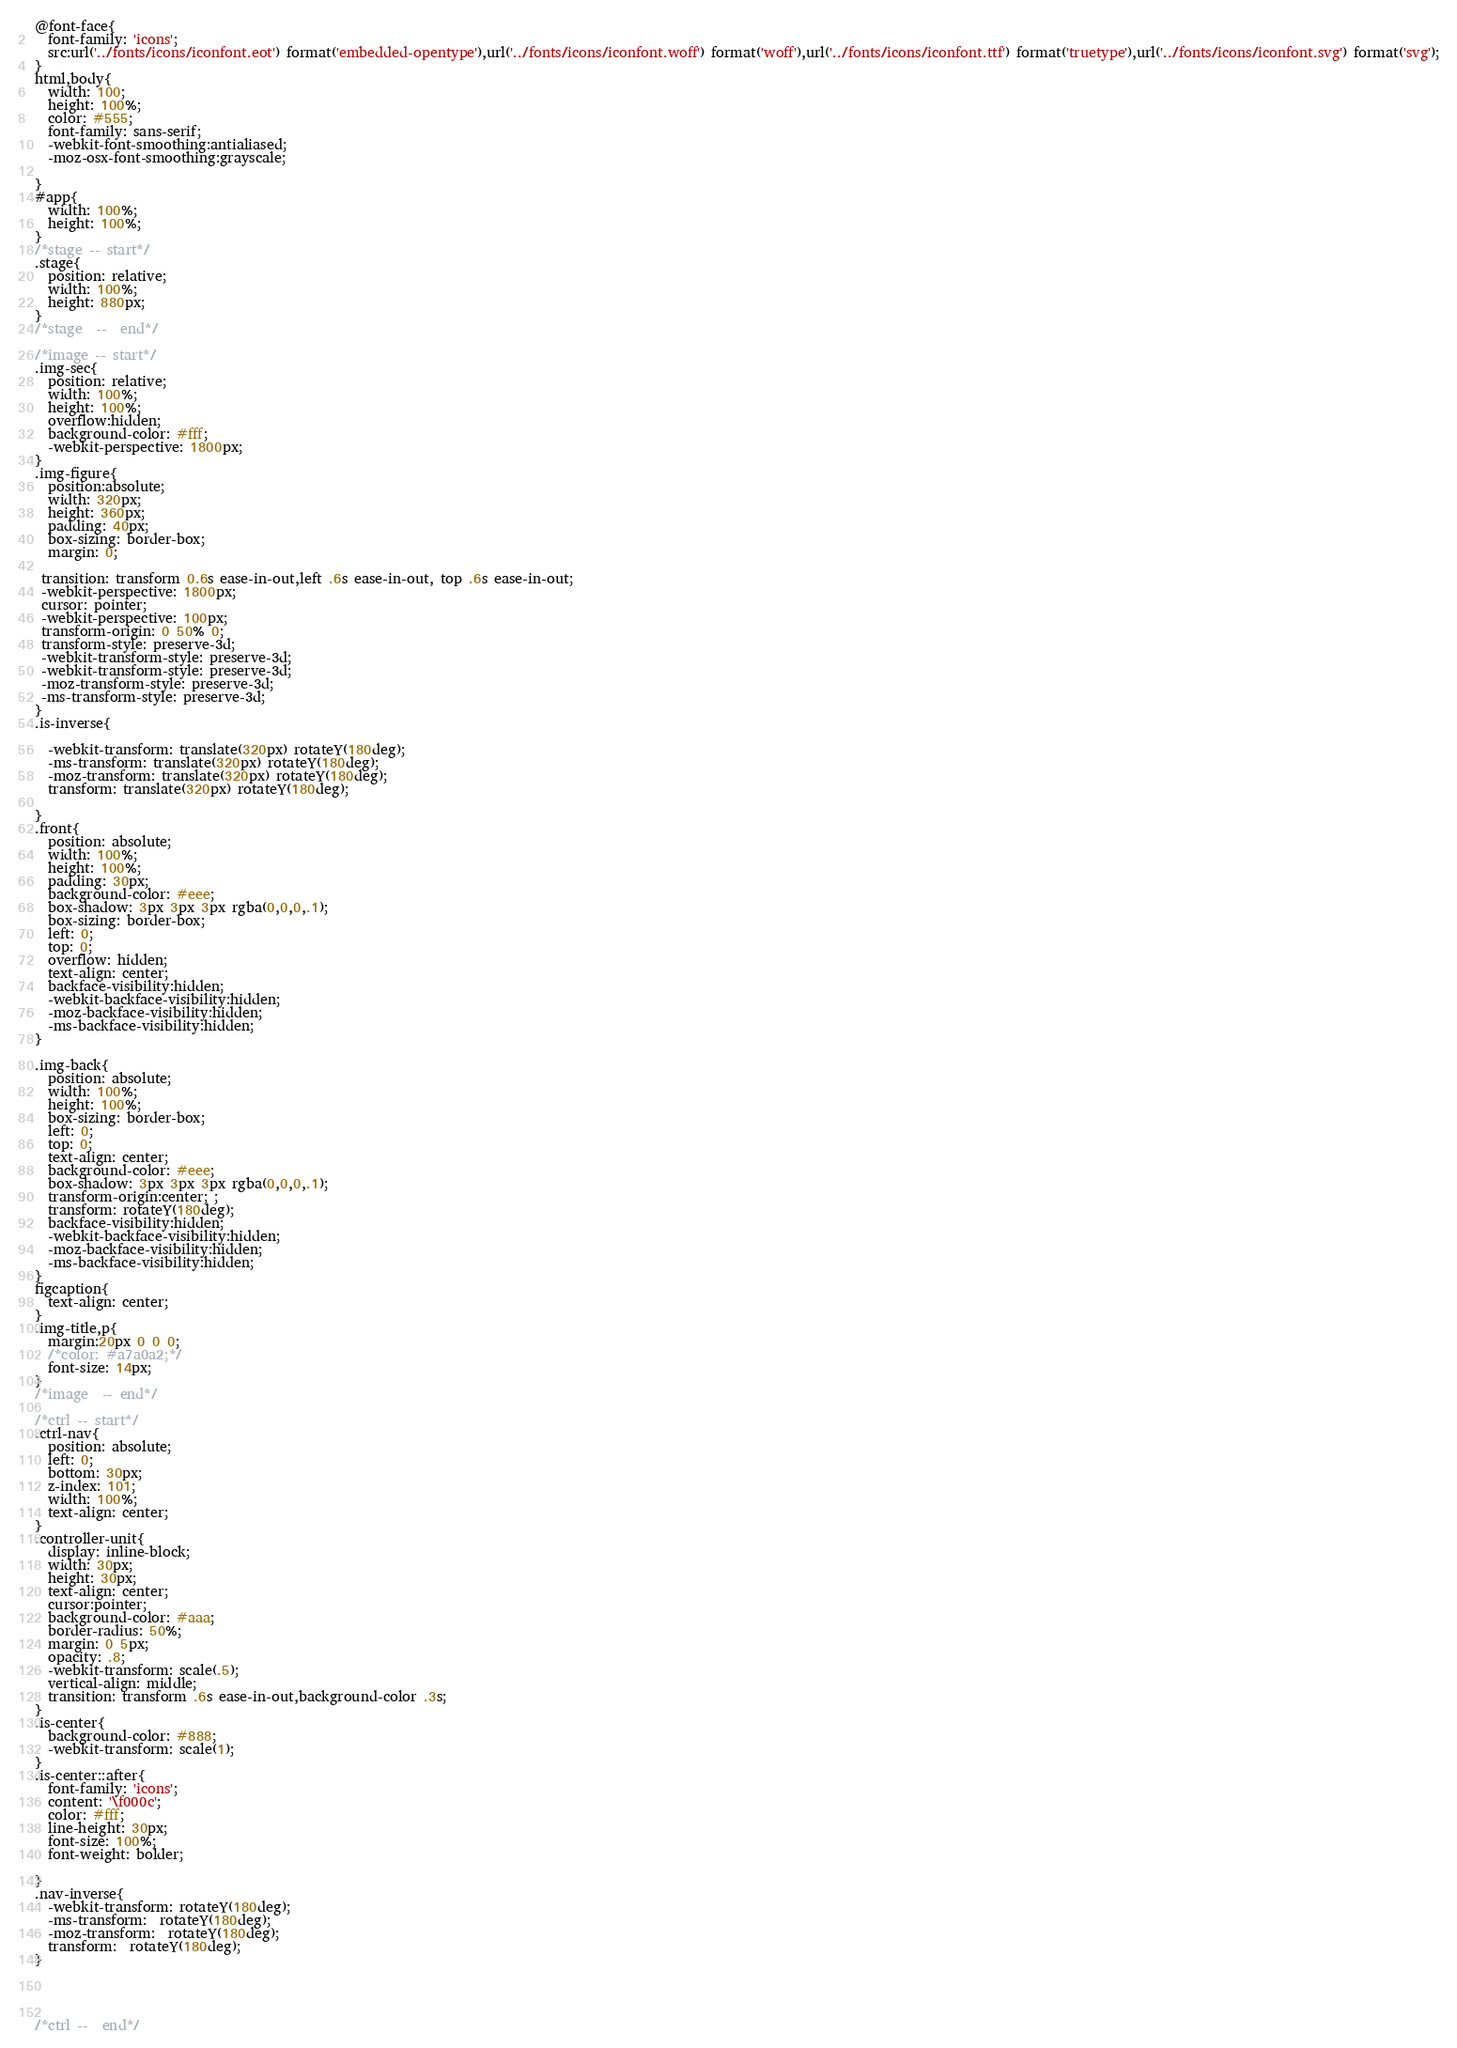<code> <loc_0><loc_0><loc_500><loc_500><_CSS_>@font-face{
  font-family: 'icons';
  src:url('../fonts/icons/iconfont.eot') format('embedded-opentype'),url('../fonts/icons/iconfont.woff') format('woff'),url('../fonts/icons/iconfont.ttf') format('truetype'),url('../fonts/icons/iconfont.svg') format('svg');
}
html,body{
  width: 100;
  height: 100%;
  color: #555;
  font-family: sans-serif;
  -webkit-font-smoothing:antialiased;
  -moz-osx-font-smoothing:grayscale;

}
#app{
  width: 100%;
  height: 100%;
}
/*stage -- start*/
.stage{
  position: relative;
  width: 100%;
  height: 880px;
}
/*stage  --  end*/

/*image -- start*/
.img-sec{
  position: relative;
  width: 100%;
  height: 100%;
  overflow:hidden;
  background-color: #fff;
  -webkit-perspective: 1800px;
}
.img-figure{
  position:absolute;
  width: 320px;
  height: 360px;
  padding: 40px;
  box-sizing: border-box;
  margin: 0;
 
 transition: transform 0.6s ease-in-out,left .6s ease-in-out, top .6s ease-in-out;
 -webkit-perspective: 1800px;
 cursor: pointer;
 -webkit-perspective: 100px;
 transform-origin: 0 50% 0;
 transform-style: preserve-3d;
 -webkit-transform-style: preserve-3d;
 -webkit-transform-style: preserve-3d;
 -moz-transform-style: preserve-3d;
 -ms-transform-style: preserve-3d;
}
.is-inverse{
 
  -webkit-transform: translate(320px) rotateY(180deg);
  -ms-transform: translate(320px) rotateY(180deg);
  -moz-transform: translate(320px) rotateY(180deg);
  transform: translate(320px) rotateY(180deg);

}
.front{
  position: absolute;
  width: 100%;
  height: 100%;
  padding: 30px;
  background-color: #eee;
  box-shadow: 3px 3px 3px rgba(0,0,0,.1);
  box-sizing: border-box;
  left: 0;
  top: 0;
  overflow: hidden;
  text-align: center;
  backface-visibility:hidden; 
  -webkit-backface-visibility:hidden; 
  -moz-backface-visibility:hidden; 
  -ms-backface-visibility:hidden; 
}

.img-back{
  position: absolute;
  width: 100%;
  height: 100%;
  box-sizing: border-box;
  left: 0;
  top: 0;
  text-align: center;
  background-color: #eee;
  box-shadow: 3px 3px 3px rgba(0,0,0,.1);
  transform-origin:center; ;
  transform: rotateY(180deg);
  backface-visibility:hidden; 
  -webkit-backface-visibility:hidden; 
  -moz-backface-visibility:hidden; 
  -ms-backface-visibility:hidden; 
}
figcaption{
  text-align: center;
}
.img-title,p{
  margin:20px 0 0 0;
  /*color: #a7a0a2;*/
  font-size: 14px;
}
/*image  -- end*/

/*ctrl -- start*/
.ctrl-nav{
  position: absolute;
  left: 0;
  bottom: 30px;
  z-index: 101;
  width: 100%;
  text-align: center;
}
.controller-unit{
  display: inline-block;
  width: 30px;
  height: 30px;
  text-align: center;
  cursor:pointer;
  background-color: #aaa;
  border-radius: 50%;
  margin: 0 5px;
  opacity: .8;
  -webkit-transform: scale(.5);
  vertical-align: middle;
  transition: transform .6s ease-in-out,background-color .3s;
}
.is-center{
  background-color: #888;
  -webkit-transform: scale(1);
}
.is-center::after{
  font-family: 'icons';
  content: '\f000c';
  color: #fff;
  line-height: 30px;
  font-size: 100%;
  font-weight: bolder;

}
.nav-inverse{
  -webkit-transform: rotateY(180deg);
  -ms-transform:  rotateY(180deg);
  -moz-transform:  rotateY(180deg);
  transform:  rotateY(180deg);
}




/*ctrl --  end*/




















</code> 